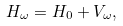Convert formula to latex. <formula><loc_0><loc_0><loc_500><loc_500>H _ { \omega } = H _ { 0 } + V _ { \omega } ,</formula> 